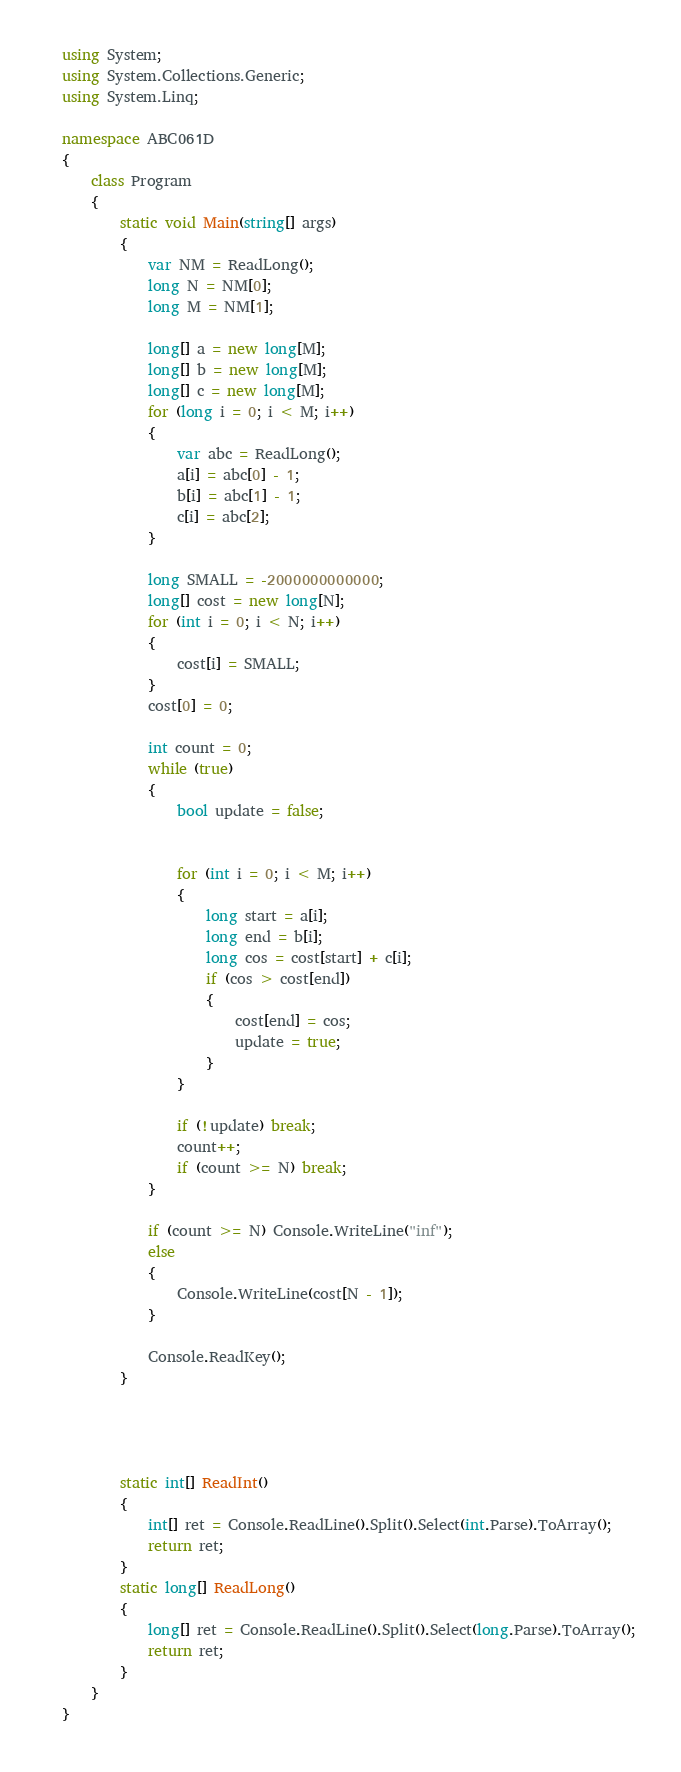Convert code to text. <code><loc_0><loc_0><loc_500><loc_500><_C#_>using System;
using System.Collections.Generic;
using System.Linq;

namespace ABC061D
{
    class Program
    {
        static void Main(string[] args)
        {
            var NM = ReadLong();
            long N = NM[0];
            long M = NM[1];

            long[] a = new long[M];
            long[] b = new long[M];
            long[] c = new long[M];
            for (long i = 0; i < M; i++)
            {
                var abc = ReadLong();
                a[i] = abc[0] - 1;
                b[i] = abc[1] - 1;
                c[i] = abc[2];
            }

            long SMALL = -2000000000000;
            long[] cost = new long[N];
            for (int i = 0; i < N; i++)
            {
                cost[i] = SMALL;
            }
            cost[0] = 0;

            int count = 0;
            while (true)
            {
                bool update = false;


                for (int i = 0; i < M; i++)
                {
                    long start = a[i];
                    long end = b[i];
                    long cos = cost[start] + c[i];
                    if (cos > cost[end])
                    {
                        cost[end] = cos;
                        update = true;
                    }
                }

                if (!update) break;
                count++;
                if (count >= N) break;
            }

            if (count >= N) Console.WriteLine("inf");
            else
            {
                Console.WriteLine(cost[N - 1]);
            }

            Console.ReadKey();
        }




        static int[] ReadInt()
        {
            int[] ret = Console.ReadLine().Split().Select(int.Parse).ToArray();
            return ret;
        }
        static long[] ReadLong()
        {
            long[] ret = Console.ReadLine().Split().Select(long.Parse).ToArray();
            return ret;
        }
    }
}
</code> 